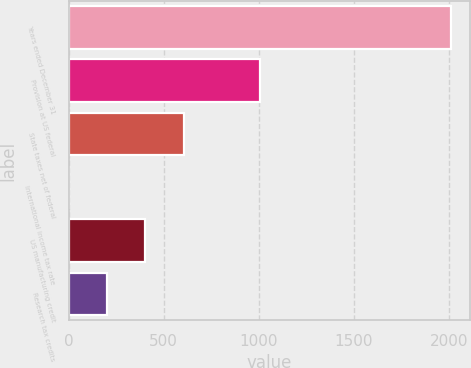Convert chart. <chart><loc_0><loc_0><loc_500><loc_500><bar_chart><fcel>Years ended December 31<fcel>Provision at US federal<fcel>State taxes net of federal<fcel>International income tax rate<fcel>US manufacturing credit<fcel>Research tax credits<nl><fcel>2014<fcel>1007.2<fcel>604.48<fcel>0.4<fcel>403.12<fcel>201.76<nl></chart> 